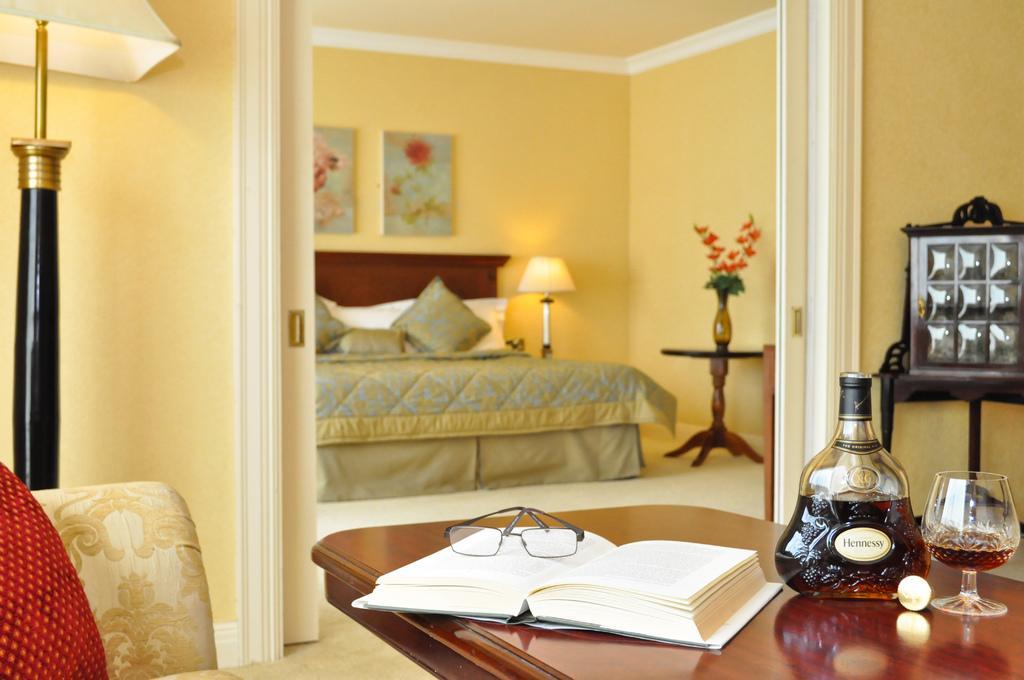Please provide a concise description of this image. In this image I see a bed, a lamp, few photo frames on the wall and tables on which there is a book, spectacle, bottle, glass and a flower vase. 